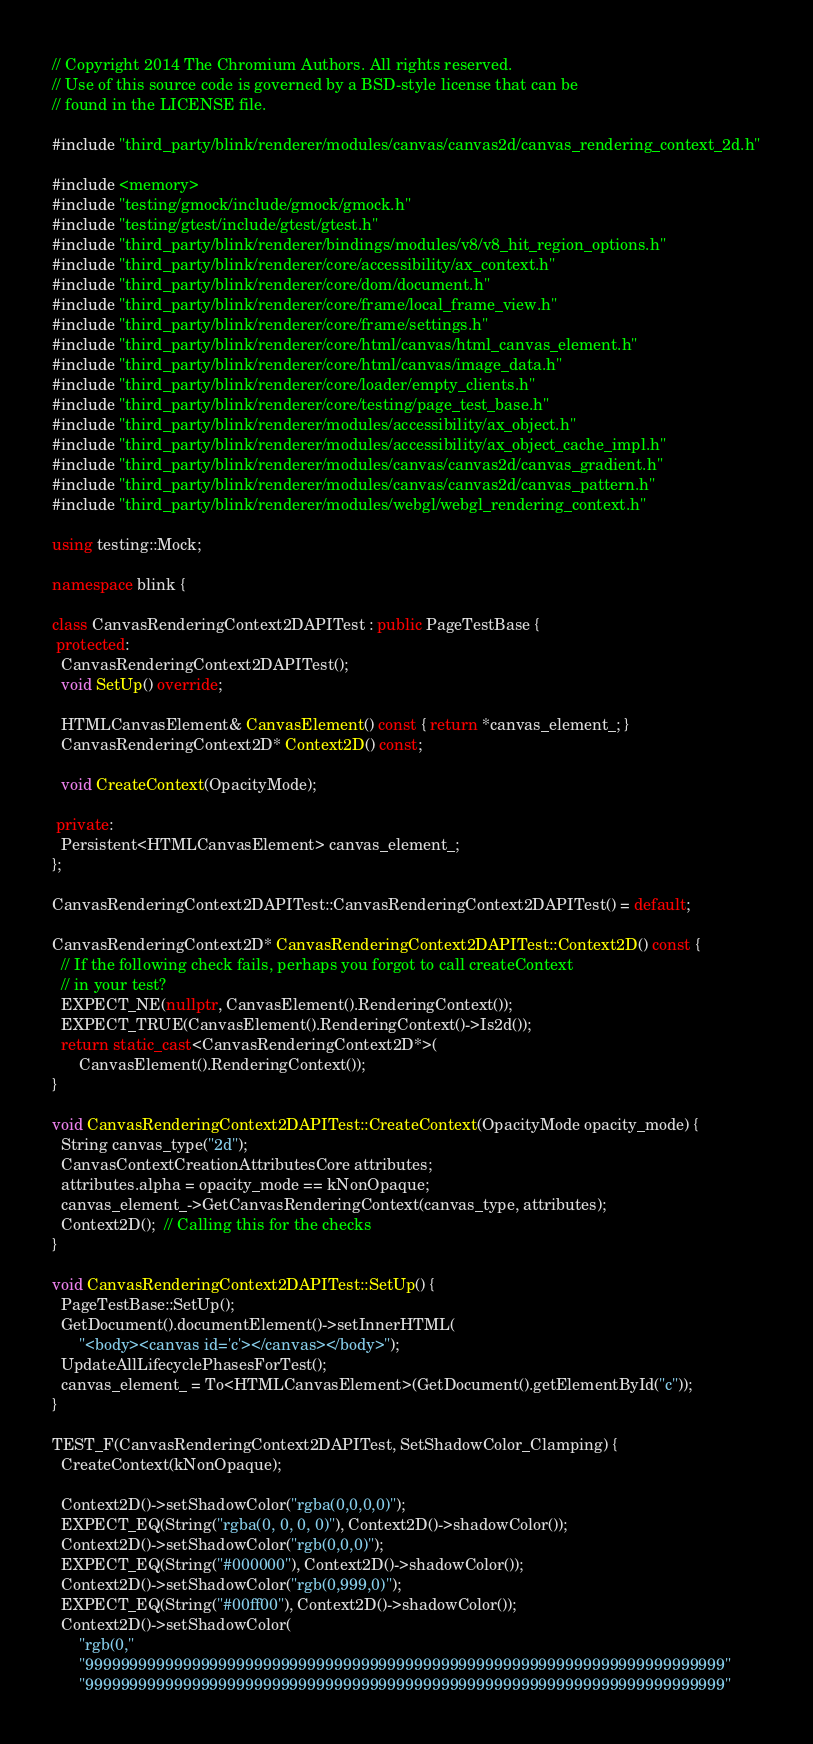Convert code to text. <code><loc_0><loc_0><loc_500><loc_500><_C++_>// Copyright 2014 The Chromium Authors. All rights reserved.
// Use of this source code is governed by a BSD-style license that can be
// found in the LICENSE file.

#include "third_party/blink/renderer/modules/canvas/canvas2d/canvas_rendering_context_2d.h"

#include <memory>
#include "testing/gmock/include/gmock/gmock.h"
#include "testing/gtest/include/gtest/gtest.h"
#include "third_party/blink/renderer/bindings/modules/v8/v8_hit_region_options.h"
#include "third_party/blink/renderer/core/accessibility/ax_context.h"
#include "third_party/blink/renderer/core/dom/document.h"
#include "third_party/blink/renderer/core/frame/local_frame_view.h"
#include "third_party/blink/renderer/core/frame/settings.h"
#include "third_party/blink/renderer/core/html/canvas/html_canvas_element.h"
#include "third_party/blink/renderer/core/html/canvas/image_data.h"
#include "third_party/blink/renderer/core/loader/empty_clients.h"
#include "third_party/blink/renderer/core/testing/page_test_base.h"
#include "third_party/blink/renderer/modules/accessibility/ax_object.h"
#include "third_party/blink/renderer/modules/accessibility/ax_object_cache_impl.h"
#include "third_party/blink/renderer/modules/canvas/canvas2d/canvas_gradient.h"
#include "third_party/blink/renderer/modules/canvas/canvas2d/canvas_pattern.h"
#include "third_party/blink/renderer/modules/webgl/webgl_rendering_context.h"

using testing::Mock;

namespace blink {

class CanvasRenderingContext2DAPITest : public PageTestBase {
 protected:
  CanvasRenderingContext2DAPITest();
  void SetUp() override;

  HTMLCanvasElement& CanvasElement() const { return *canvas_element_; }
  CanvasRenderingContext2D* Context2D() const;

  void CreateContext(OpacityMode);

 private:
  Persistent<HTMLCanvasElement> canvas_element_;
};

CanvasRenderingContext2DAPITest::CanvasRenderingContext2DAPITest() = default;

CanvasRenderingContext2D* CanvasRenderingContext2DAPITest::Context2D() const {
  // If the following check fails, perhaps you forgot to call createContext
  // in your test?
  EXPECT_NE(nullptr, CanvasElement().RenderingContext());
  EXPECT_TRUE(CanvasElement().RenderingContext()->Is2d());
  return static_cast<CanvasRenderingContext2D*>(
      CanvasElement().RenderingContext());
}

void CanvasRenderingContext2DAPITest::CreateContext(OpacityMode opacity_mode) {
  String canvas_type("2d");
  CanvasContextCreationAttributesCore attributes;
  attributes.alpha = opacity_mode == kNonOpaque;
  canvas_element_->GetCanvasRenderingContext(canvas_type, attributes);
  Context2D();  // Calling this for the checks
}

void CanvasRenderingContext2DAPITest::SetUp() {
  PageTestBase::SetUp();
  GetDocument().documentElement()->setInnerHTML(
      "<body><canvas id='c'></canvas></body>");
  UpdateAllLifecyclePhasesForTest();
  canvas_element_ = To<HTMLCanvasElement>(GetDocument().getElementById("c"));
}

TEST_F(CanvasRenderingContext2DAPITest, SetShadowColor_Clamping) {
  CreateContext(kNonOpaque);

  Context2D()->setShadowColor("rgba(0,0,0,0)");
  EXPECT_EQ(String("rgba(0, 0, 0, 0)"), Context2D()->shadowColor());
  Context2D()->setShadowColor("rgb(0,0,0)");
  EXPECT_EQ(String("#000000"), Context2D()->shadowColor());
  Context2D()->setShadowColor("rgb(0,999,0)");
  EXPECT_EQ(String("#00ff00"), Context2D()->shadowColor());
  Context2D()->setShadowColor(
      "rgb(0,"
      "999999999999999999999999999999999999999999999999999999999999999999999999"
      "999999999999999999999999999999999999999999999999999999999999999999999999"</code> 